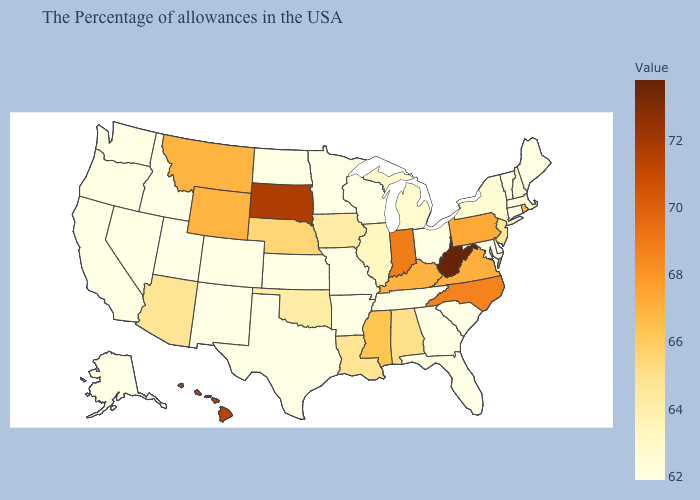Does Wyoming have a lower value than Indiana?
Concise answer only. Yes. Does West Virginia have the highest value in the South?
Keep it brief. Yes. Which states hav the highest value in the South?
Give a very brief answer. West Virginia. 